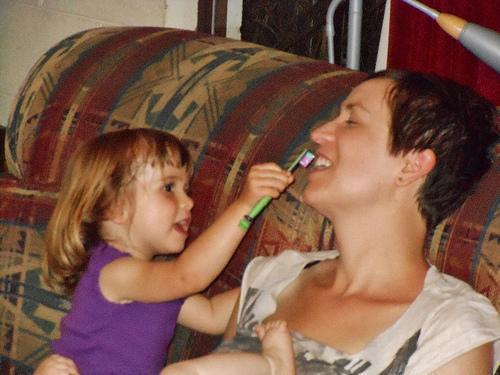How many earrings are shown?
Give a very brief answer. 1. How many people are in the image?
Give a very brief answer. 2. 